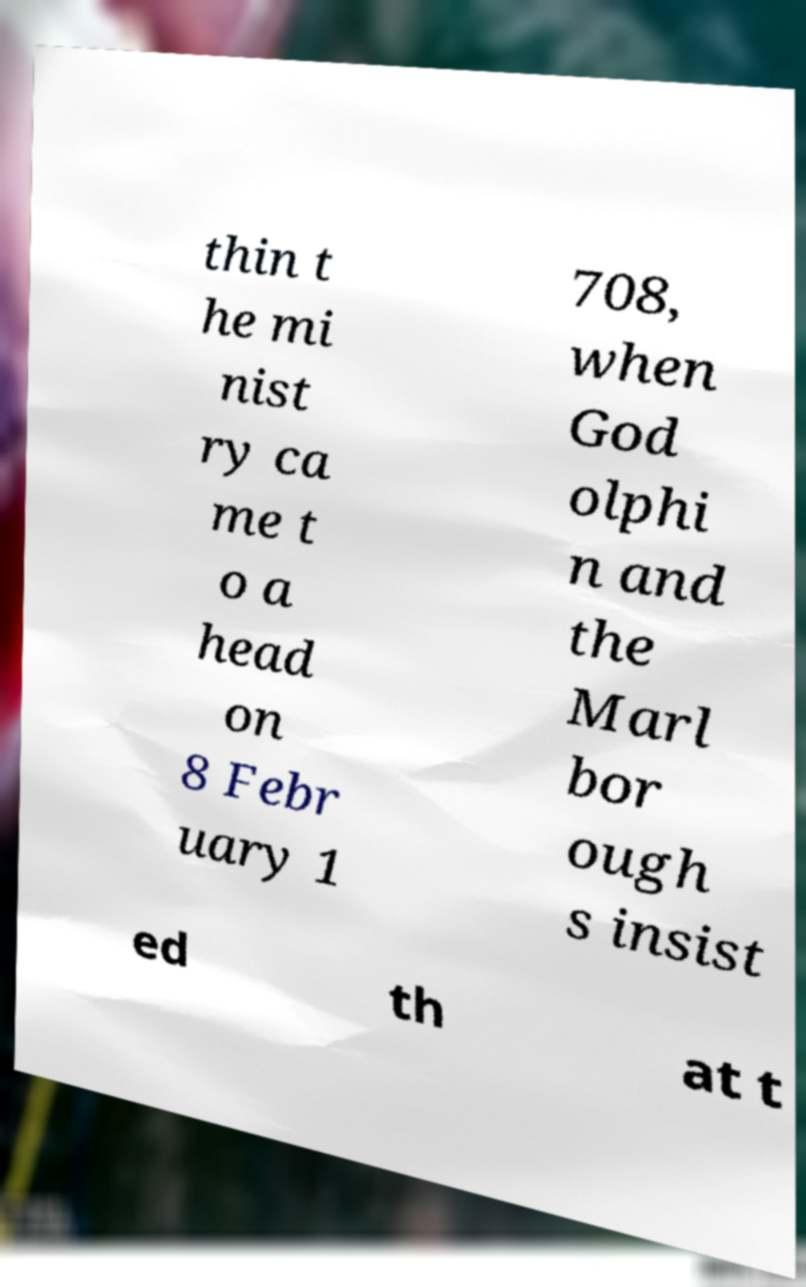There's text embedded in this image that I need extracted. Can you transcribe it verbatim? thin t he mi nist ry ca me t o a head on 8 Febr uary 1 708, when God olphi n and the Marl bor ough s insist ed th at t 